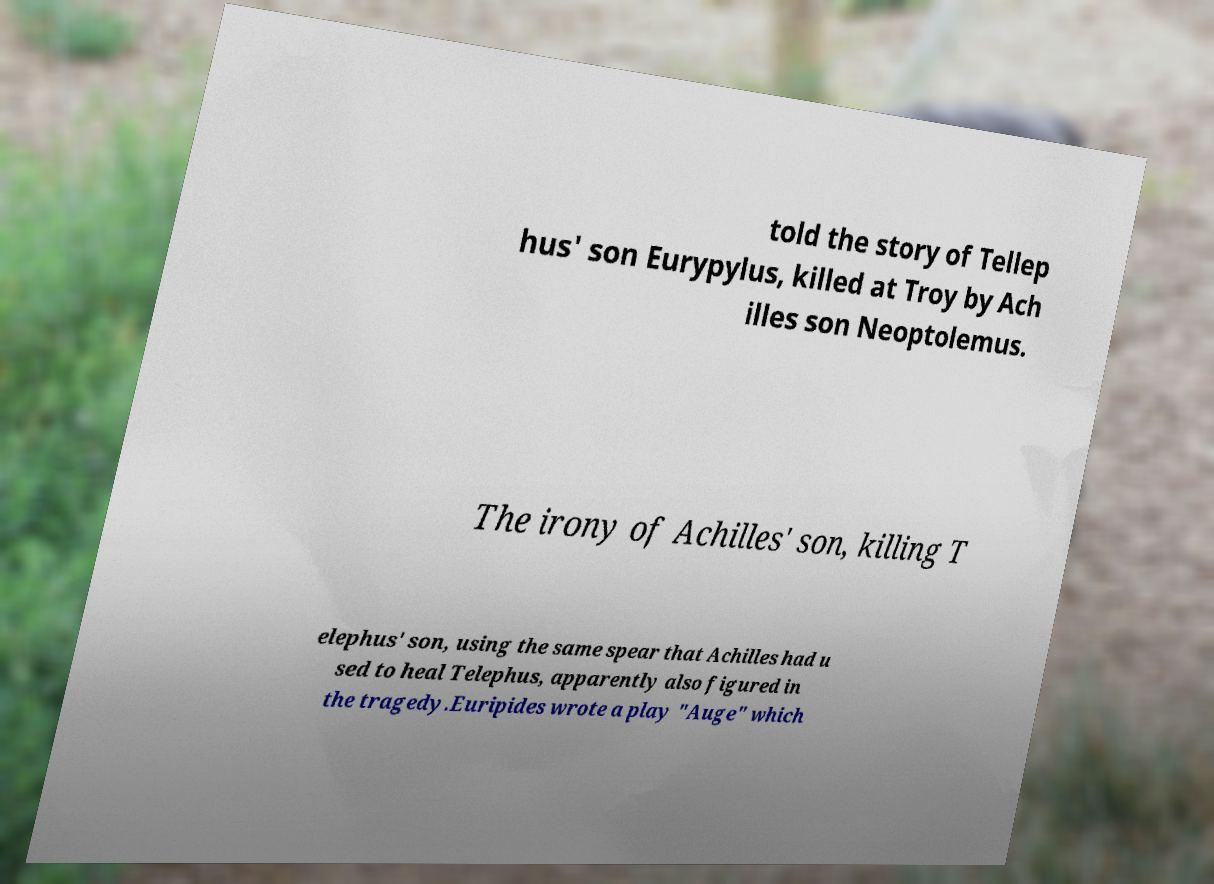Please read and relay the text visible in this image. What does it say? told the story of Tellep hus' son Eurypylus, killed at Troy by Ach illes son Neoptolemus. The irony of Achilles' son, killing T elephus' son, using the same spear that Achilles had u sed to heal Telephus, apparently also figured in the tragedy.Euripides wrote a play "Auge" which 